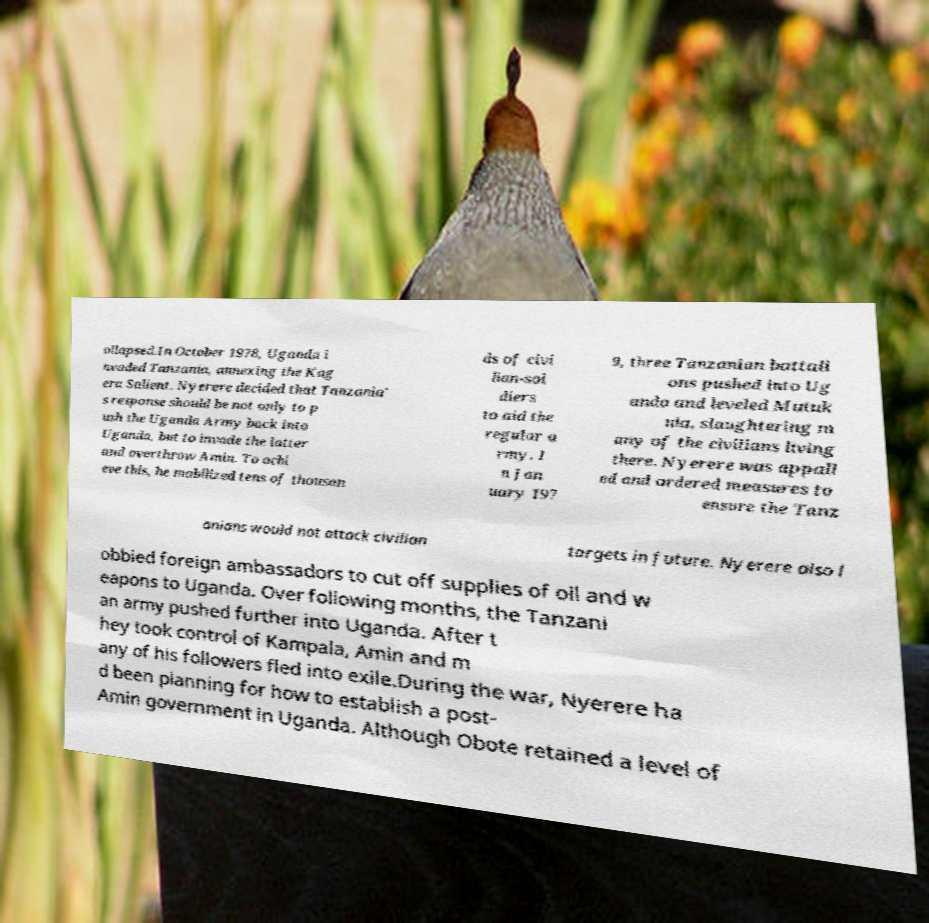There's text embedded in this image that I need extracted. Can you transcribe it verbatim? ollapsed.In October 1978, Uganda i nvaded Tanzania, annexing the Kag era Salient. Nyerere decided that Tanzania' s response should be not only to p ush the Uganda Army back into Uganda, but to invade the latter and overthrow Amin. To achi eve this, he mobilized tens of thousan ds of civi lian-sol diers to aid the regular a rmy. I n Jan uary 197 9, three Tanzanian battali ons pushed into Ug anda and leveled Mutuk ula, slaughtering m any of the civilians living there. Nyerere was appall ed and ordered measures to ensure the Tanz anians would not attack civilian targets in future. Nyerere also l obbied foreign ambassadors to cut off supplies of oil and w eapons to Uganda. Over following months, the Tanzani an army pushed further into Uganda. After t hey took control of Kampala, Amin and m any of his followers fled into exile.During the war, Nyerere ha d been planning for how to establish a post- Amin government in Uganda. Although Obote retained a level of 